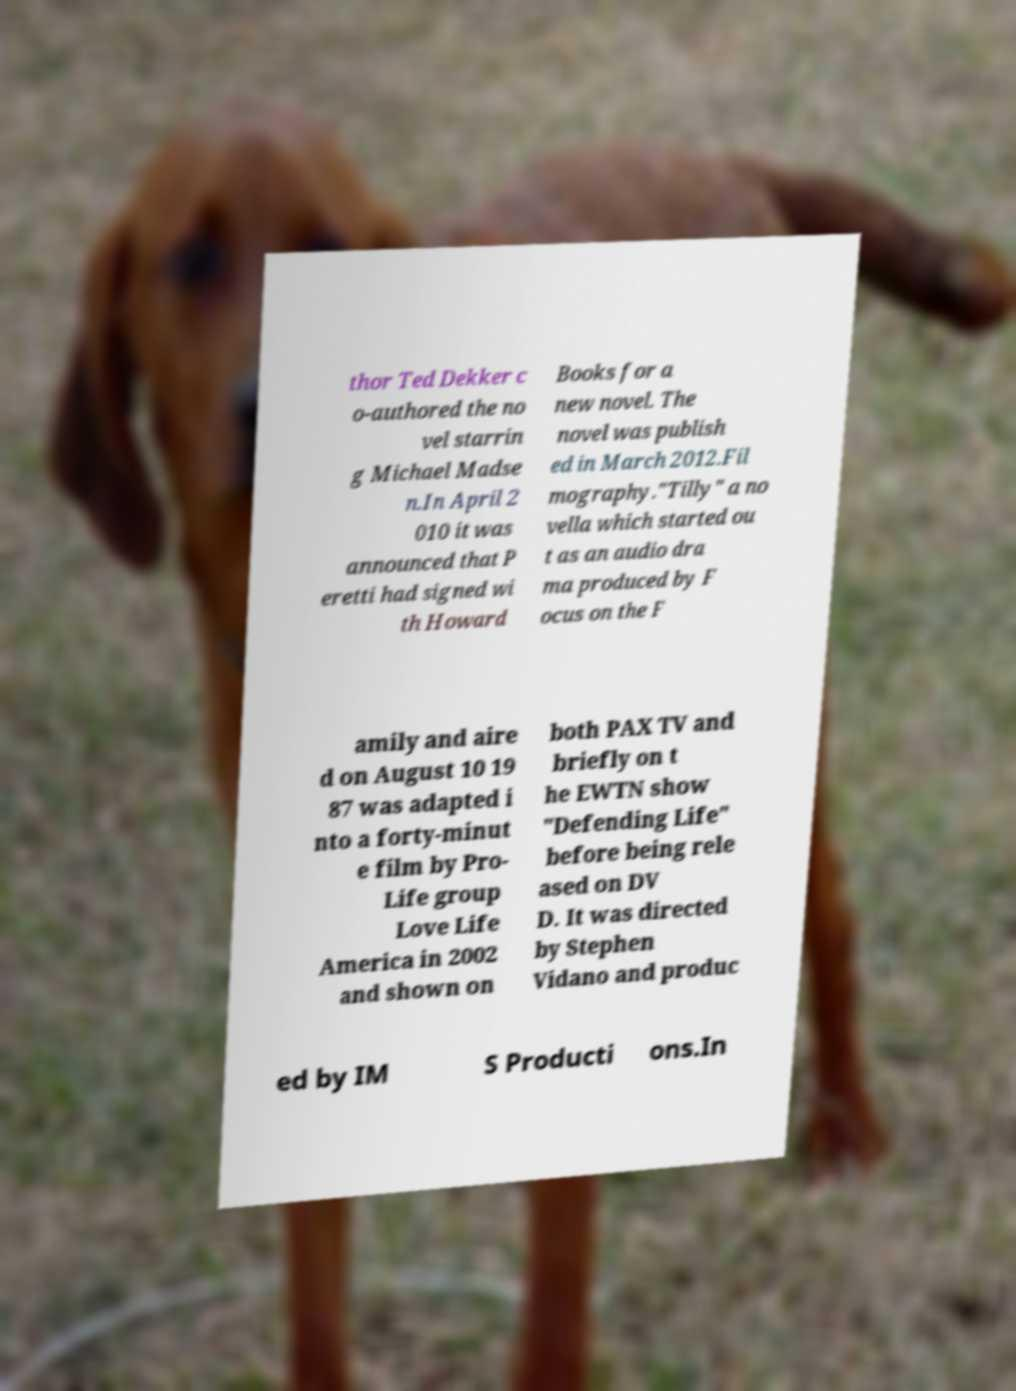I need the written content from this picture converted into text. Can you do that? thor Ted Dekker c o-authored the no vel starrin g Michael Madse n.In April 2 010 it was announced that P eretti had signed wi th Howard Books for a new novel. The novel was publish ed in March 2012.Fil mography."Tilly" a no vella which started ou t as an audio dra ma produced by F ocus on the F amily and aire d on August 10 19 87 was adapted i nto a forty-minut e film by Pro- Life group Love Life America in 2002 and shown on both PAX TV and briefly on t he EWTN show "Defending Life" before being rele ased on DV D. It was directed by Stephen Vidano and produc ed by IM S Producti ons.In 